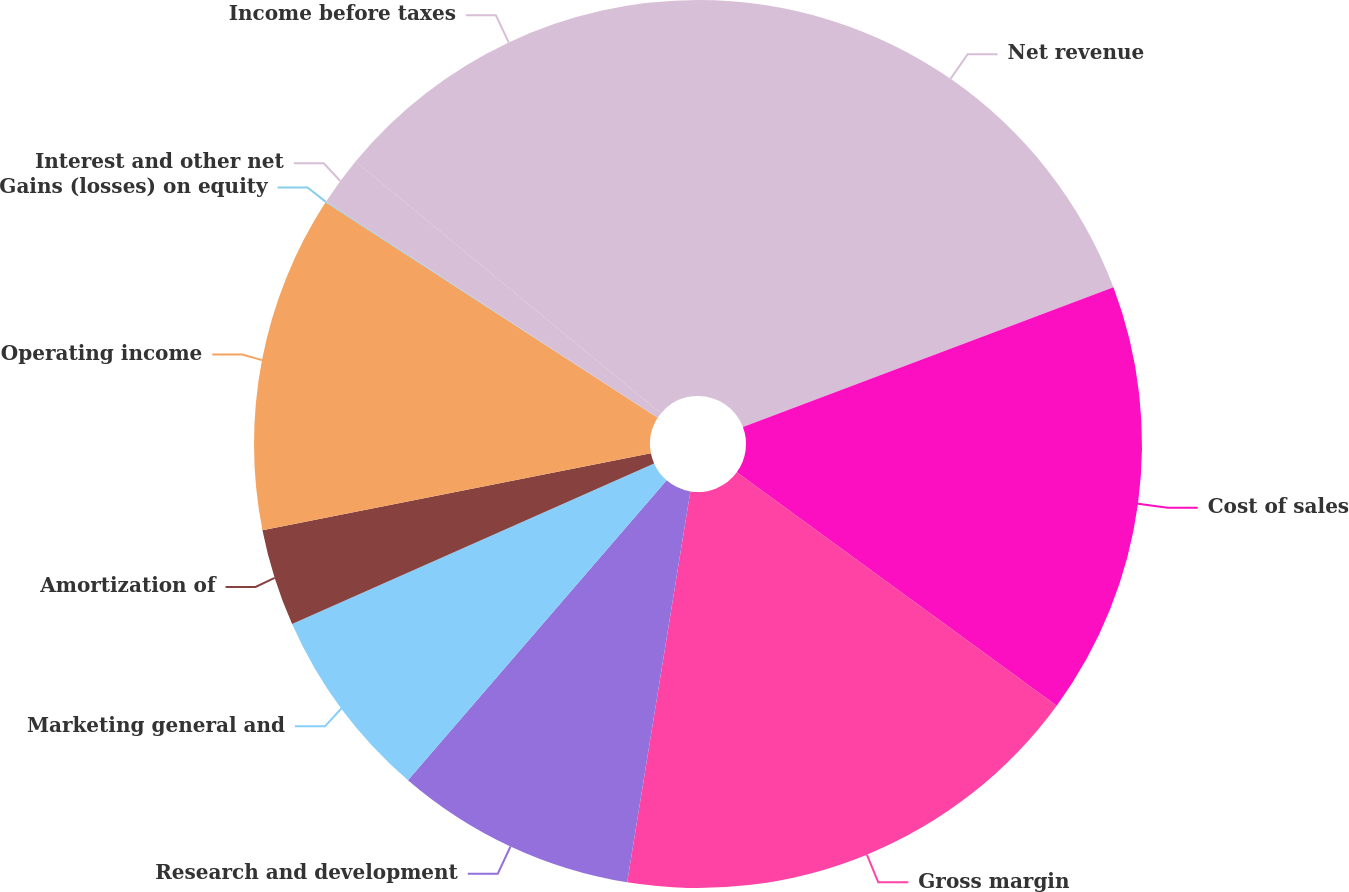Convert chart. <chart><loc_0><loc_0><loc_500><loc_500><pie_chart><fcel>Net revenue<fcel>Cost of sales<fcel>Gross margin<fcel>Research and development<fcel>Marketing general and<fcel>Amortization of<fcel>Operating income<fcel>Gains (losses) on equity<fcel>Interest and other net<fcel>Income before taxes<nl><fcel>19.26%<fcel>15.77%<fcel>17.52%<fcel>8.78%<fcel>7.03%<fcel>3.53%<fcel>12.27%<fcel>0.04%<fcel>1.78%<fcel>14.02%<nl></chart> 